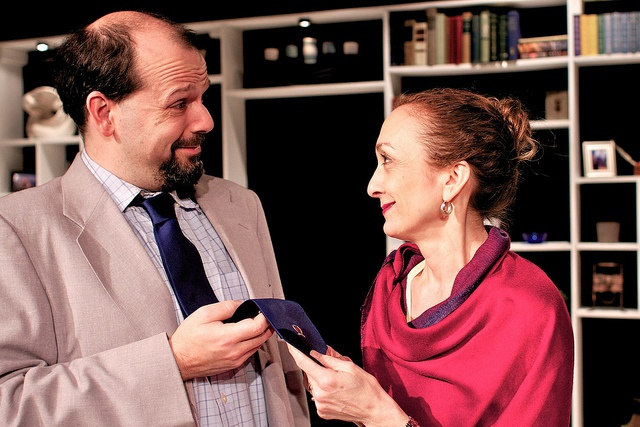Describe the objects in this image and their specific colors. I can see people in black, lightpink, darkgray, and brown tones, people in black, salmon, maroon, and tan tones, tie in black, navy, and purple tones, book in black, maroon, and gray tones, and book in black, gray, and tan tones in this image. 